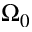<formula> <loc_0><loc_0><loc_500><loc_500>\Omega _ { 0 }</formula> 